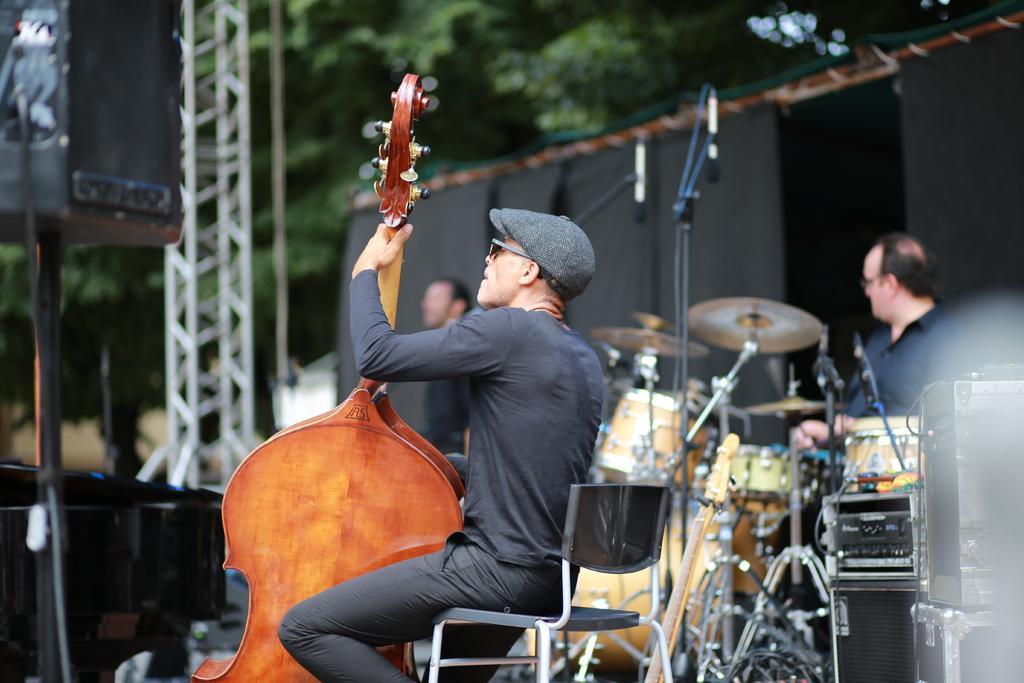Could you give a brief overview of what you see in this image? In this image I can see a man sitting on the chair and playing cello musical instrument. He is wearing cap and goggles. At background I can see a mike with a mike stand. And a person is standing and playing drums. At the right corner of the image I can see some devices placed. At the left corner of the image I can see a speaker with the stand. 